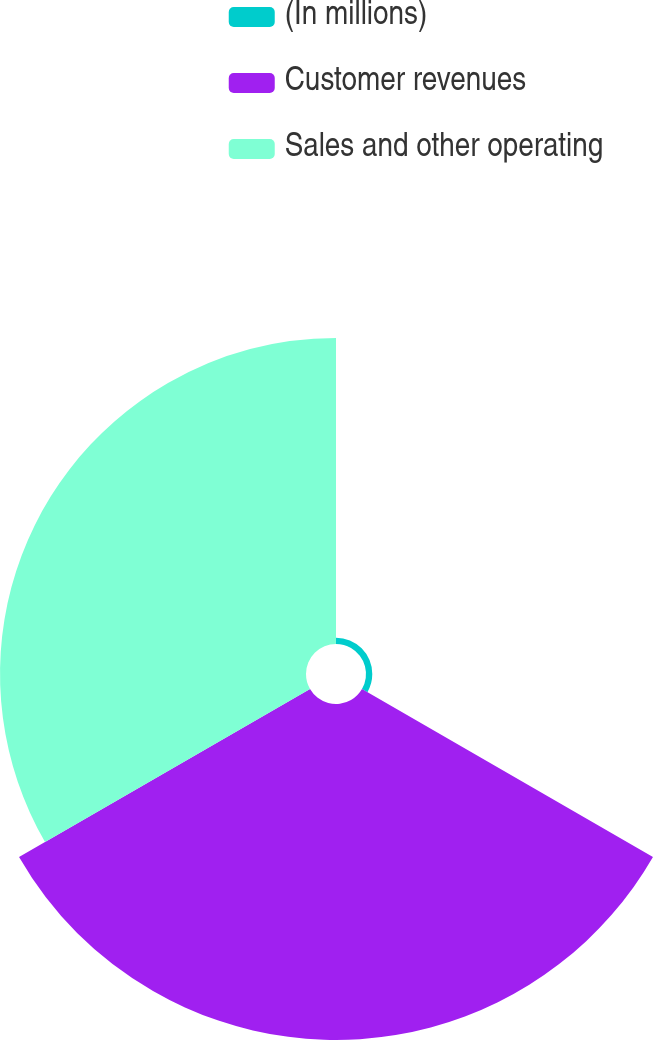Convert chart to OTSL. <chart><loc_0><loc_0><loc_500><loc_500><pie_chart><fcel>(In millions)<fcel>Customer revenues<fcel>Sales and other operating<nl><fcel>0.97%<fcel>51.83%<fcel>47.2%<nl></chart> 